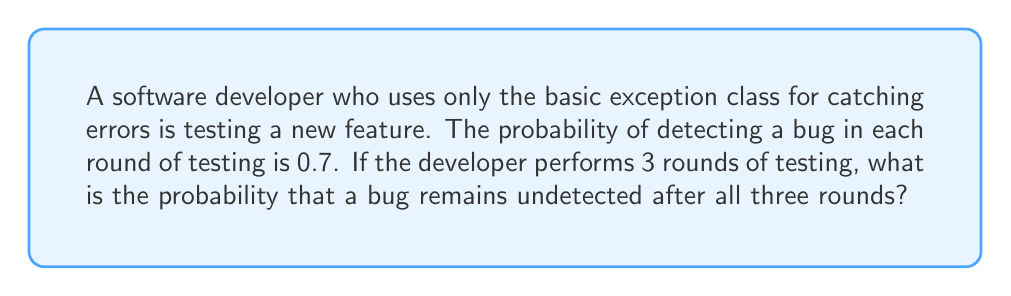Give your solution to this math problem. Let's approach this step-by-step:

1) First, we need to understand what the question is asking. We're looking for the probability that a bug remains undetected after 3 rounds of testing.

2) We're given that the probability of detecting a bug in each round is 0.7. This means the probability of not detecting a bug in each round is 1 - 0.7 = 0.3.

3) For the bug to remain undetected after all three rounds, it must go undetected in round 1 AND round 2 AND round 3.

4) Since each round is independent, we can multiply the probabilities:

   $$ P(\text{undetected}) = 0.3 \times 0.3 \times 0.3 = 0.3^3 $$

5) Let's calculate this:

   $$ 0.3^3 = 0.027 $$

6) Therefore, the probability that a bug remains undetected after 3 rounds of testing is 0.027 or 2.7%.

This result shows that even with a relatively high detection rate per round (70%), there's still a non-negligible chance of a bug slipping through multiple rounds of testing. This underscores the importance of thorough testing and proper error handling in software development.
Answer: The probability that a bug remains undetected after 3 rounds of testing is 0.027 or 2.7%. 